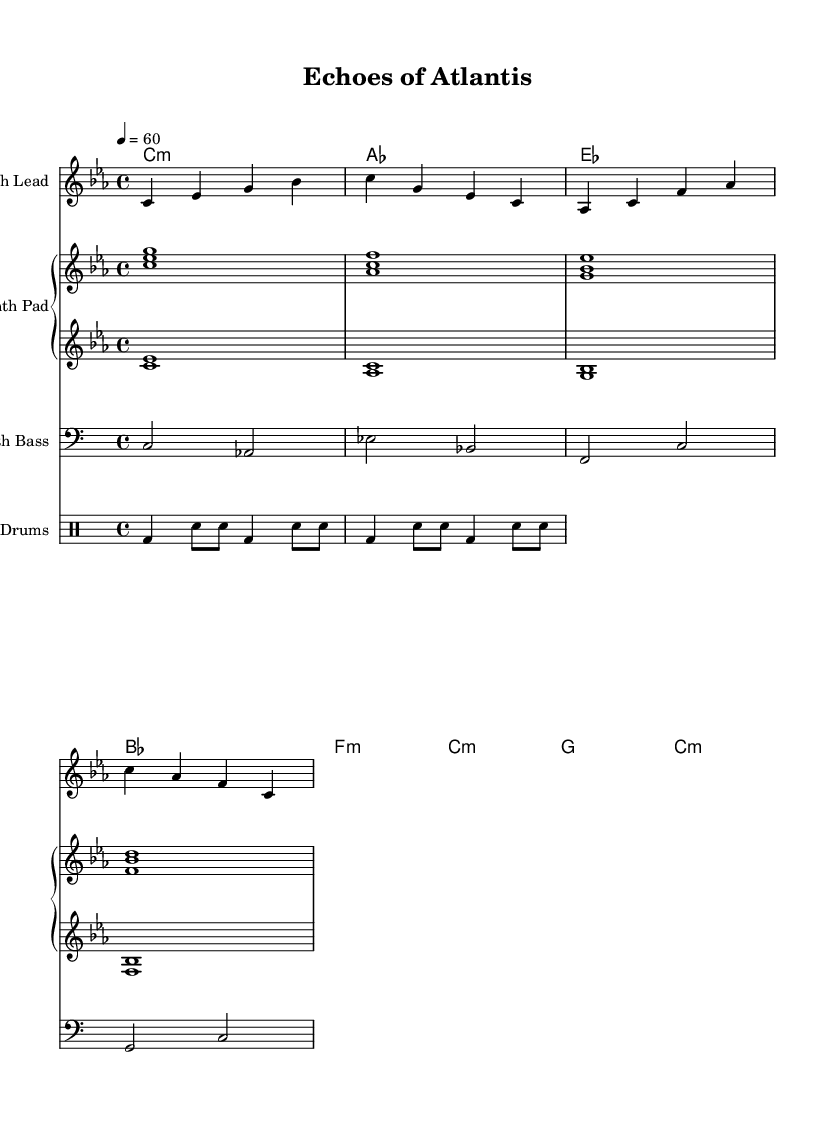What is the key signature of this music? The key signature is indicated at the beginning of the score and is C minor, which has three flats (B♭, E♭, A♭).
Answer: C minor What is the time signature of this piece? The time signature appears at the beginning of the score, where it denotes a 4/4 time, indicating four beats per measure.
Answer: 4/4 What is the tempo marking? The tempo marking can be found at the start of the score, showing a metronome marking of 60 beats per minute.
Answer: 60 How many measures are in the melody? Counting the measures in the melody section, there are a total of four measures visible in the notation.
Answer: 4 What is the instrument used for the bass line? The bass line is specifically noted with a clef, which in this case is a bass clef, indicating the instrument's role as a low-frequency sound source.
Answer: Synth Bass What kind of drum pattern is used in the piece? The drum pattern is notated in the E. Drums staff, where the rhythmic structure showcases a combination of bass drum and snare placements.
Answer: Bass and Snare What chords are introduced in the harmony section? The harmony section introduces a sequence of chords written in chord symbols, beginning with C minor and followed by A♭, E♭, and B♭.
Answer: C minor 